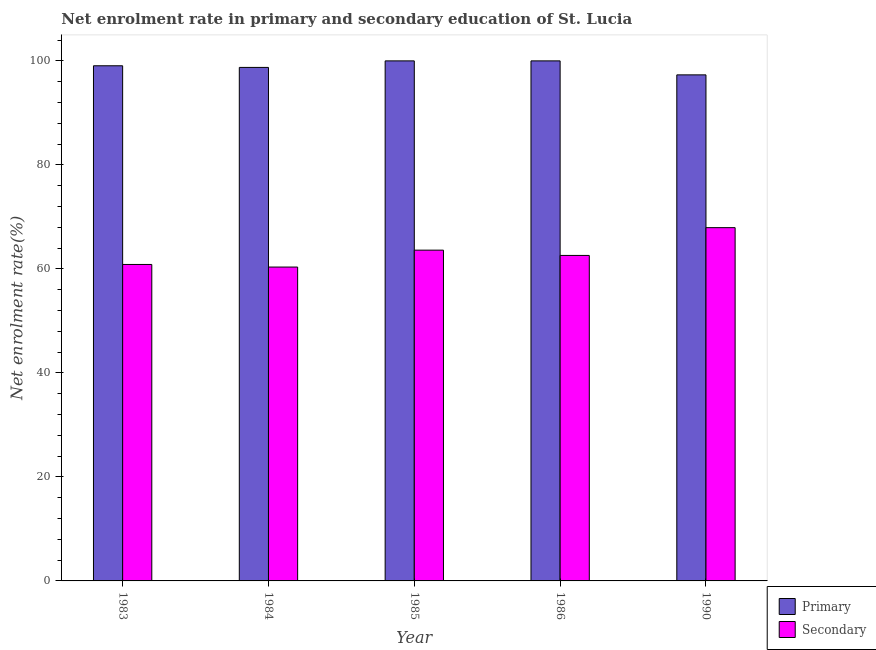How many bars are there on the 1st tick from the left?
Provide a succinct answer. 2. How many bars are there on the 5th tick from the right?
Keep it short and to the point. 2. What is the label of the 1st group of bars from the left?
Offer a very short reply. 1983. What is the enrollment rate in primary education in 1984?
Make the answer very short. 98.74. Across all years, what is the minimum enrollment rate in primary education?
Your answer should be very brief. 97.31. In which year was the enrollment rate in primary education maximum?
Offer a terse response. 1985. In which year was the enrollment rate in secondary education minimum?
Ensure brevity in your answer.  1984. What is the total enrollment rate in secondary education in the graph?
Your answer should be very brief. 315.33. What is the difference between the enrollment rate in secondary education in 1984 and that in 1986?
Offer a very short reply. -2.24. What is the difference between the enrollment rate in secondary education in 1986 and the enrollment rate in primary education in 1983?
Give a very brief answer. 1.74. What is the average enrollment rate in primary education per year?
Provide a succinct answer. 99.02. What is the ratio of the enrollment rate in secondary education in 1985 to that in 1990?
Give a very brief answer. 0.94. Is the enrollment rate in primary education in 1984 less than that in 1990?
Offer a terse response. No. What is the difference between the highest and the lowest enrollment rate in secondary education?
Offer a very short reply. 7.58. What does the 1st bar from the left in 1983 represents?
Provide a succinct answer. Primary. What does the 2nd bar from the right in 1983 represents?
Ensure brevity in your answer.  Primary. How many bars are there?
Provide a succinct answer. 10. What is the difference between two consecutive major ticks on the Y-axis?
Provide a short and direct response. 20. Does the graph contain any zero values?
Give a very brief answer. No. Does the graph contain grids?
Keep it short and to the point. No. What is the title of the graph?
Offer a terse response. Net enrolment rate in primary and secondary education of St. Lucia. Does "Technicians" appear as one of the legend labels in the graph?
Give a very brief answer. No. What is the label or title of the Y-axis?
Your answer should be very brief. Net enrolment rate(%). What is the Net enrolment rate(%) in Primary in 1983?
Offer a terse response. 99.06. What is the Net enrolment rate(%) in Secondary in 1983?
Your answer should be compact. 60.85. What is the Net enrolment rate(%) of Primary in 1984?
Give a very brief answer. 98.74. What is the Net enrolment rate(%) in Secondary in 1984?
Ensure brevity in your answer.  60.35. What is the Net enrolment rate(%) in Secondary in 1985?
Your answer should be compact. 63.61. What is the Net enrolment rate(%) in Primary in 1986?
Provide a succinct answer. 100. What is the Net enrolment rate(%) in Secondary in 1986?
Make the answer very short. 62.59. What is the Net enrolment rate(%) in Primary in 1990?
Give a very brief answer. 97.31. What is the Net enrolment rate(%) of Secondary in 1990?
Provide a succinct answer. 67.93. Across all years, what is the maximum Net enrolment rate(%) in Primary?
Offer a very short reply. 100. Across all years, what is the maximum Net enrolment rate(%) in Secondary?
Your answer should be compact. 67.93. Across all years, what is the minimum Net enrolment rate(%) in Primary?
Offer a very short reply. 97.31. Across all years, what is the minimum Net enrolment rate(%) in Secondary?
Your response must be concise. 60.35. What is the total Net enrolment rate(%) in Primary in the graph?
Make the answer very short. 495.11. What is the total Net enrolment rate(%) of Secondary in the graph?
Give a very brief answer. 315.33. What is the difference between the Net enrolment rate(%) in Primary in 1983 and that in 1984?
Make the answer very short. 0.31. What is the difference between the Net enrolment rate(%) of Secondary in 1983 and that in 1984?
Provide a succinct answer. 0.5. What is the difference between the Net enrolment rate(%) of Primary in 1983 and that in 1985?
Make the answer very short. -0.94. What is the difference between the Net enrolment rate(%) in Secondary in 1983 and that in 1985?
Provide a short and direct response. -2.75. What is the difference between the Net enrolment rate(%) of Primary in 1983 and that in 1986?
Keep it short and to the point. -0.94. What is the difference between the Net enrolment rate(%) of Secondary in 1983 and that in 1986?
Ensure brevity in your answer.  -1.74. What is the difference between the Net enrolment rate(%) of Primary in 1983 and that in 1990?
Give a very brief answer. 1.75. What is the difference between the Net enrolment rate(%) in Secondary in 1983 and that in 1990?
Make the answer very short. -7.08. What is the difference between the Net enrolment rate(%) of Primary in 1984 and that in 1985?
Offer a terse response. -1.26. What is the difference between the Net enrolment rate(%) in Secondary in 1984 and that in 1985?
Your answer should be very brief. -3.25. What is the difference between the Net enrolment rate(%) of Primary in 1984 and that in 1986?
Make the answer very short. -1.26. What is the difference between the Net enrolment rate(%) in Secondary in 1984 and that in 1986?
Your answer should be very brief. -2.24. What is the difference between the Net enrolment rate(%) of Primary in 1984 and that in 1990?
Your answer should be very brief. 1.43. What is the difference between the Net enrolment rate(%) in Secondary in 1984 and that in 1990?
Make the answer very short. -7.58. What is the difference between the Net enrolment rate(%) of Primary in 1985 and that in 1986?
Provide a short and direct response. 0. What is the difference between the Net enrolment rate(%) of Primary in 1985 and that in 1990?
Make the answer very short. 2.69. What is the difference between the Net enrolment rate(%) in Secondary in 1985 and that in 1990?
Your answer should be very brief. -4.33. What is the difference between the Net enrolment rate(%) in Primary in 1986 and that in 1990?
Keep it short and to the point. 2.69. What is the difference between the Net enrolment rate(%) in Secondary in 1986 and that in 1990?
Offer a very short reply. -5.34. What is the difference between the Net enrolment rate(%) of Primary in 1983 and the Net enrolment rate(%) of Secondary in 1984?
Provide a succinct answer. 38.71. What is the difference between the Net enrolment rate(%) of Primary in 1983 and the Net enrolment rate(%) of Secondary in 1985?
Provide a succinct answer. 35.45. What is the difference between the Net enrolment rate(%) in Primary in 1983 and the Net enrolment rate(%) in Secondary in 1986?
Give a very brief answer. 36.47. What is the difference between the Net enrolment rate(%) of Primary in 1983 and the Net enrolment rate(%) of Secondary in 1990?
Provide a succinct answer. 31.13. What is the difference between the Net enrolment rate(%) of Primary in 1984 and the Net enrolment rate(%) of Secondary in 1985?
Your answer should be compact. 35.14. What is the difference between the Net enrolment rate(%) in Primary in 1984 and the Net enrolment rate(%) in Secondary in 1986?
Provide a succinct answer. 36.16. What is the difference between the Net enrolment rate(%) in Primary in 1984 and the Net enrolment rate(%) in Secondary in 1990?
Your answer should be very brief. 30.81. What is the difference between the Net enrolment rate(%) of Primary in 1985 and the Net enrolment rate(%) of Secondary in 1986?
Give a very brief answer. 37.41. What is the difference between the Net enrolment rate(%) of Primary in 1985 and the Net enrolment rate(%) of Secondary in 1990?
Offer a terse response. 32.07. What is the difference between the Net enrolment rate(%) in Primary in 1986 and the Net enrolment rate(%) in Secondary in 1990?
Ensure brevity in your answer.  32.07. What is the average Net enrolment rate(%) in Primary per year?
Your answer should be compact. 99.02. What is the average Net enrolment rate(%) of Secondary per year?
Offer a very short reply. 63.07. In the year 1983, what is the difference between the Net enrolment rate(%) of Primary and Net enrolment rate(%) of Secondary?
Provide a short and direct response. 38.21. In the year 1984, what is the difference between the Net enrolment rate(%) of Primary and Net enrolment rate(%) of Secondary?
Make the answer very short. 38.39. In the year 1985, what is the difference between the Net enrolment rate(%) of Primary and Net enrolment rate(%) of Secondary?
Make the answer very short. 36.4. In the year 1986, what is the difference between the Net enrolment rate(%) in Primary and Net enrolment rate(%) in Secondary?
Keep it short and to the point. 37.41. In the year 1990, what is the difference between the Net enrolment rate(%) in Primary and Net enrolment rate(%) in Secondary?
Your answer should be very brief. 29.38. What is the ratio of the Net enrolment rate(%) in Secondary in 1983 to that in 1984?
Provide a short and direct response. 1.01. What is the ratio of the Net enrolment rate(%) of Primary in 1983 to that in 1985?
Your answer should be very brief. 0.99. What is the ratio of the Net enrolment rate(%) of Secondary in 1983 to that in 1985?
Offer a terse response. 0.96. What is the ratio of the Net enrolment rate(%) of Primary in 1983 to that in 1986?
Provide a succinct answer. 0.99. What is the ratio of the Net enrolment rate(%) of Secondary in 1983 to that in 1986?
Make the answer very short. 0.97. What is the ratio of the Net enrolment rate(%) in Secondary in 1983 to that in 1990?
Provide a short and direct response. 0.9. What is the ratio of the Net enrolment rate(%) in Primary in 1984 to that in 1985?
Give a very brief answer. 0.99. What is the ratio of the Net enrolment rate(%) of Secondary in 1984 to that in 1985?
Make the answer very short. 0.95. What is the ratio of the Net enrolment rate(%) of Primary in 1984 to that in 1986?
Your answer should be very brief. 0.99. What is the ratio of the Net enrolment rate(%) in Secondary in 1984 to that in 1986?
Keep it short and to the point. 0.96. What is the ratio of the Net enrolment rate(%) of Primary in 1984 to that in 1990?
Your answer should be compact. 1.01. What is the ratio of the Net enrolment rate(%) in Secondary in 1984 to that in 1990?
Your answer should be compact. 0.89. What is the ratio of the Net enrolment rate(%) of Primary in 1985 to that in 1986?
Offer a very short reply. 1. What is the ratio of the Net enrolment rate(%) in Secondary in 1985 to that in 1986?
Make the answer very short. 1.02. What is the ratio of the Net enrolment rate(%) of Primary in 1985 to that in 1990?
Provide a succinct answer. 1.03. What is the ratio of the Net enrolment rate(%) in Secondary in 1985 to that in 1990?
Keep it short and to the point. 0.94. What is the ratio of the Net enrolment rate(%) of Primary in 1986 to that in 1990?
Ensure brevity in your answer.  1.03. What is the ratio of the Net enrolment rate(%) in Secondary in 1986 to that in 1990?
Your answer should be compact. 0.92. What is the difference between the highest and the second highest Net enrolment rate(%) of Primary?
Your answer should be compact. 0. What is the difference between the highest and the second highest Net enrolment rate(%) in Secondary?
Make the answer very short. 4.33. What is the difference between the highest and the lowest Net enrolment rate(%) of Primary?
Your answer should be very brief. 2.69. What is the difference between the highest and the lowest Net enrolment rate(%) of Secondary?
Make the answer very short. 7.58. 